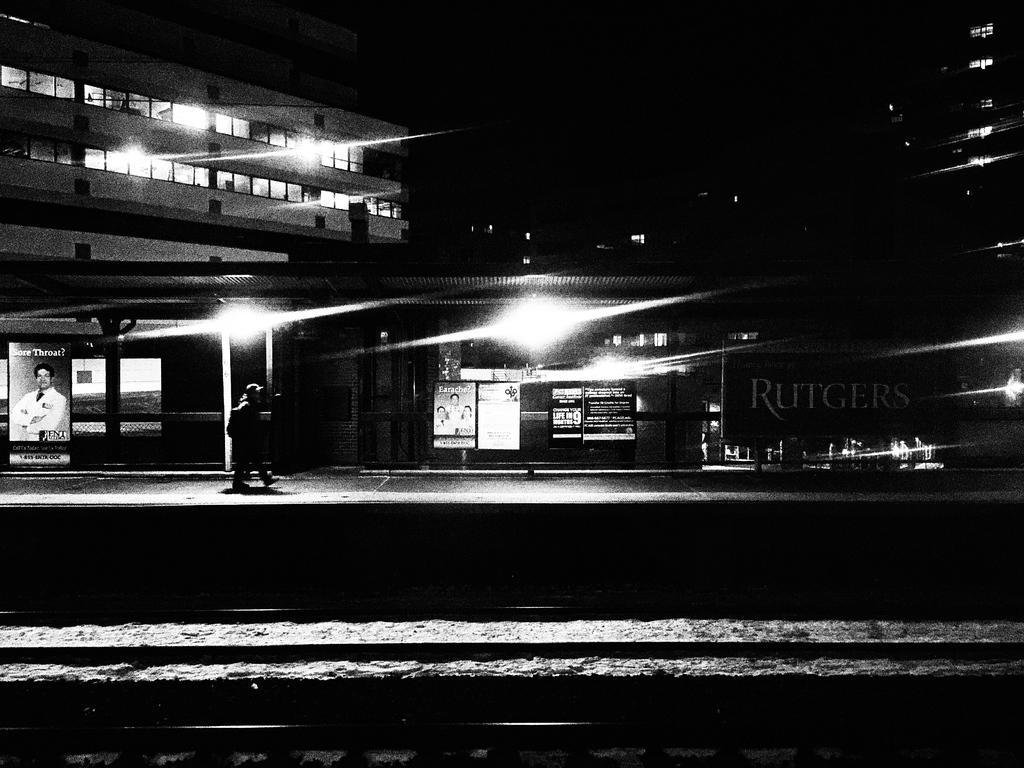Please provide a concise description of this image. In this black and white picture there is a person walking on a walkway. There is a shed on the walkway. Below the shed there are boards. On the boards there are the pictures of people and text. In the background there are buildings. At the bottom there is a wall. The image is dark. 